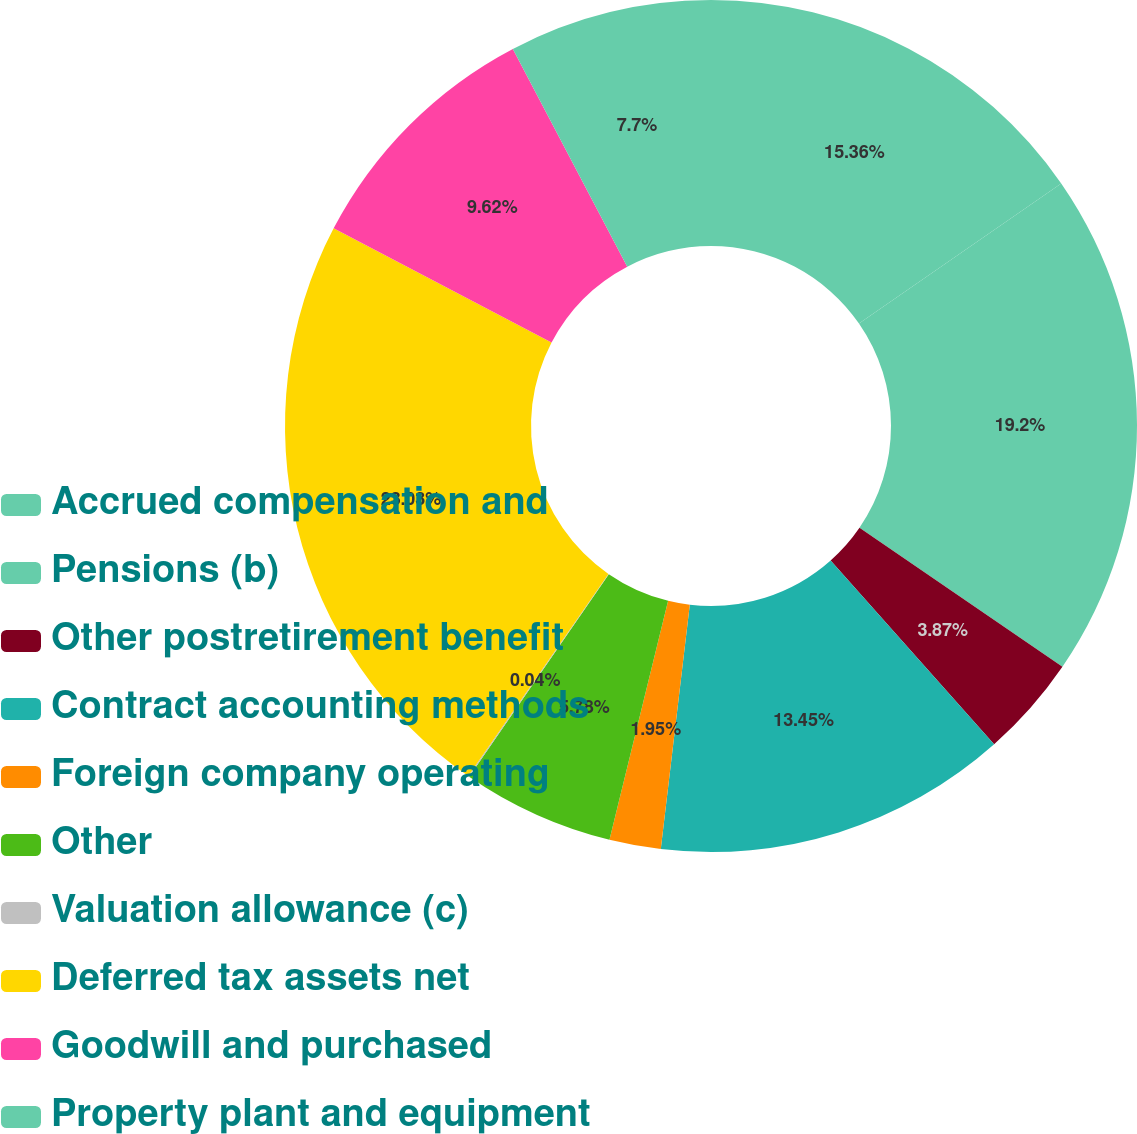Convert chart. <chart><loc_0><loc_0><loc_500><loc_500><pie_chart><fcel>Accrued compensation and<fcel>Pensions (b)<fcel>Other postretirement benefit<fcel>Contract accounting methods<fcel>Foreign company operating<fcel>Other<fcel>Valuation allowance (c)<fcel>Deferred tax assets net<fcel>Goodwill and purchased<fcel>Property plant and equipment<nl><fcel>15.36%<fcel>19.2%<fcel>3.87%<fcel>13.45%<fcel>1.95%<fcel>5.78%<fcel>0.04%<fcel>23.03%<fcel>9.62%<fcel>7.7%<nl></chart> 